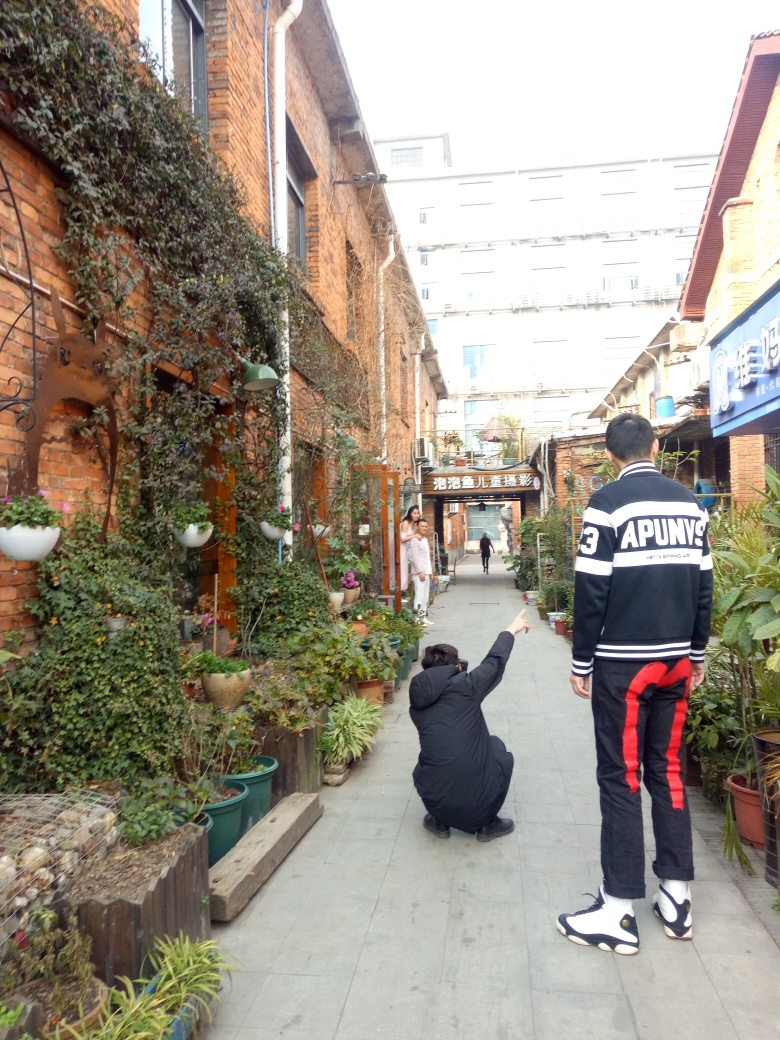What is the overall clarity of this image?
A. Poor
B. Excellent
C. Acceptable The overall clarity of the image is acceptable. The subjects and surroundings are visible, though the image could be sharper for enhanced details. Adjusting the focus and exposure might improve clarity. 